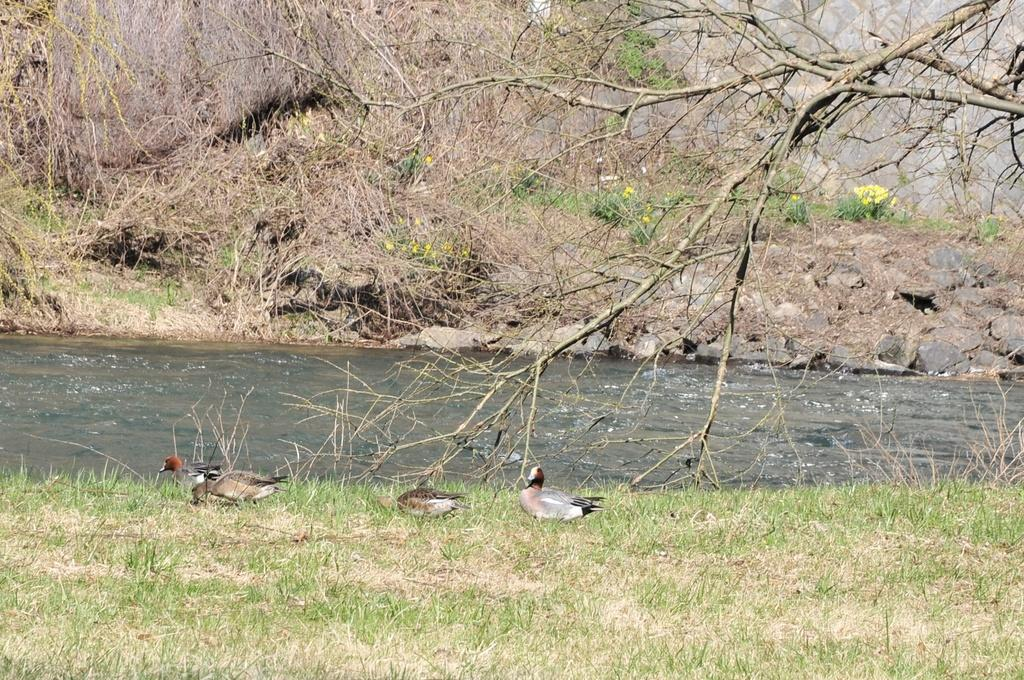What type of animals are on the ground in the image? There are birds on the ground in the image. What can be seen in the distance behind the birds? Water, grass, and trees are visible in the background of the image. What type of terrain is visible in the background of the image? Grass and trees are visible in the background of the image. What other objects can be seen on the ground in the background of the image? There are other objects visible on the ground in the background of the image. What type of waves can be seen in the image? There are no waves visible in the image; it features birds on the ground and a background with water, grass, and trees. 